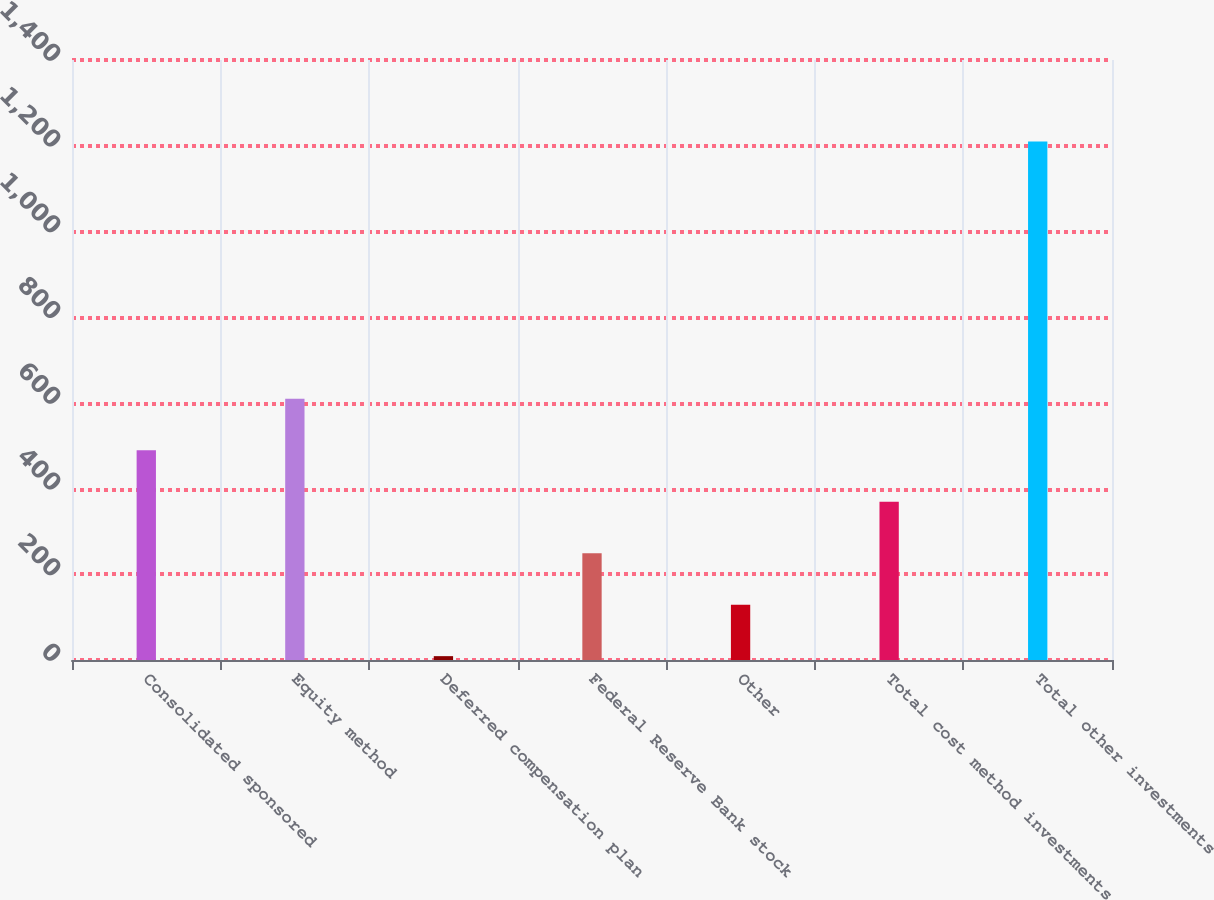Convert chart. <chart><loc_0><loc_0><loc_500><loc_500><bar_chart><fcel>Consolidated sponsored<fcel>Equity method<fcel>Deferred compensation plan<fcel>Federal Reserve Bank stock<fcel>Other<fcel>Total cost method investments<fcel>Total other investments<nl><fcel>489.4<fcel>609.5<fcel>9<fcel>249.2<fcel>129.1<fcel>369.3<fcel>1210<nl></chart> 